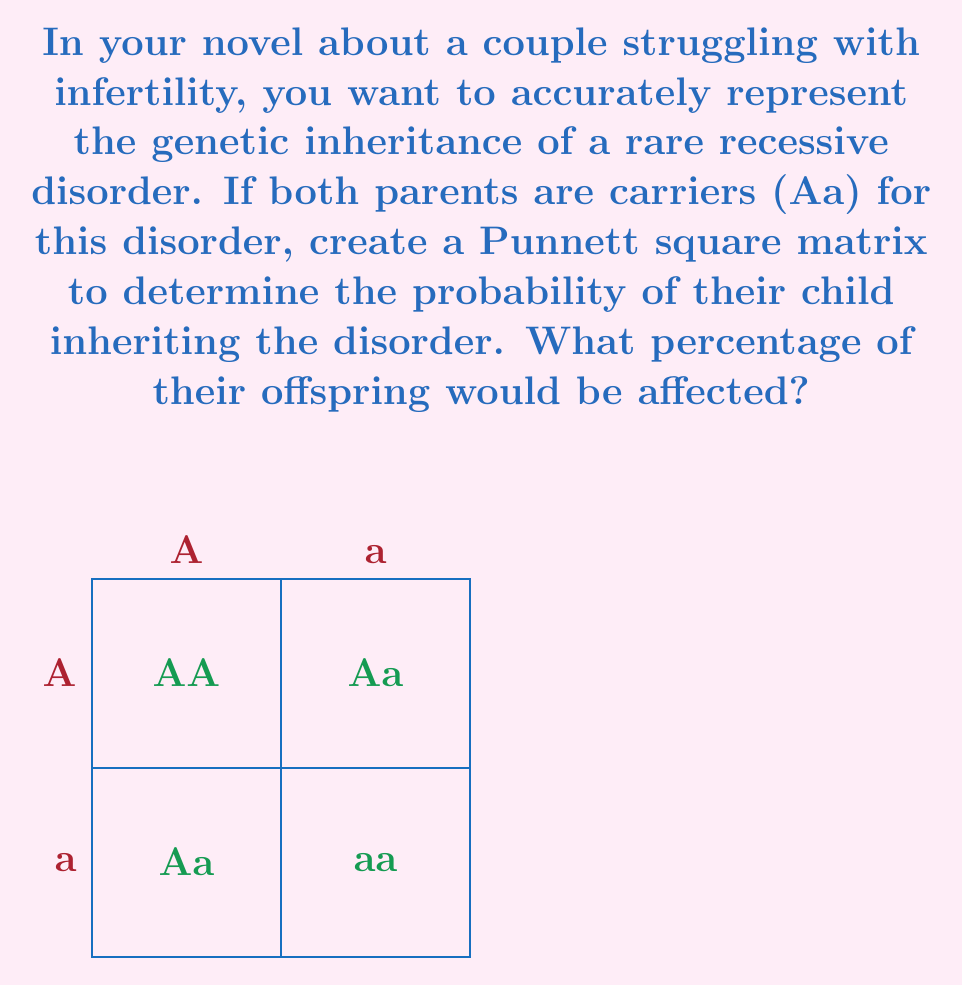Give your solution to this math problem. To solve this problem, we'll follow these steps:

1) First, let's understand the Punnett square matrix:
   - 'A' represents the dominant allele (normal)
   - 'a' represents the recessive allele (disorder)
   - 'Aa' means the individual is a carrier

2) The Punnett square shows all possible combinations of alleles:
   $$\begin{bmatrix}
   AA & Aa \\
   Aa & aa
   \end{bmatrix}$$

3) Analyze the outcomes:
   - AA: Unaffected (normal)
   - Aa: Carrier (unaffected)
   - aa: Affected (has the disorder)

4) Count the occurrences:
   - 1 AA (unaffected)
   - 2 Aa (carriers)
   - 1 aa (affected)

5) Calculate the probability:
   - Total outcomes: 4
   - Affected outcomes: 1
   - Probability = $\frac{\text{Affected outcomes}}{\text{Total outcomes}} = \frac{1}{4}$

6) Convert to percentage:
   $\frac{1}{4} \times 100\% = 25\%$

Therefore, 25% of their offspring would be affected by the disorder.
Answer: 25% 